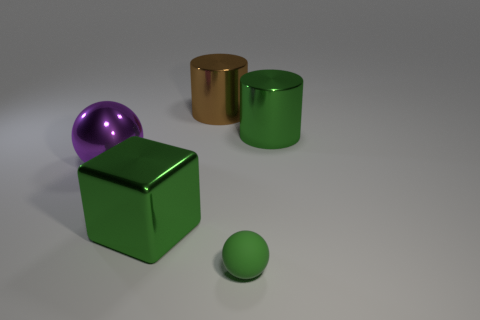How does the lighting affect the appearance of the objects? The lighting in the image creates subtle shadows and highlights, which give a sense of three-dimensionality to the objects. It seems to be coming from above and to the left, casting shadows to the bottom right of the objects and accentuating their textures. The glossy surfaces of the purple sphere and parts of the brown cylinder reflect the light sharply, while the more matte surfaces of the green cube and cylinder diffuse the light, softening their appearance. 